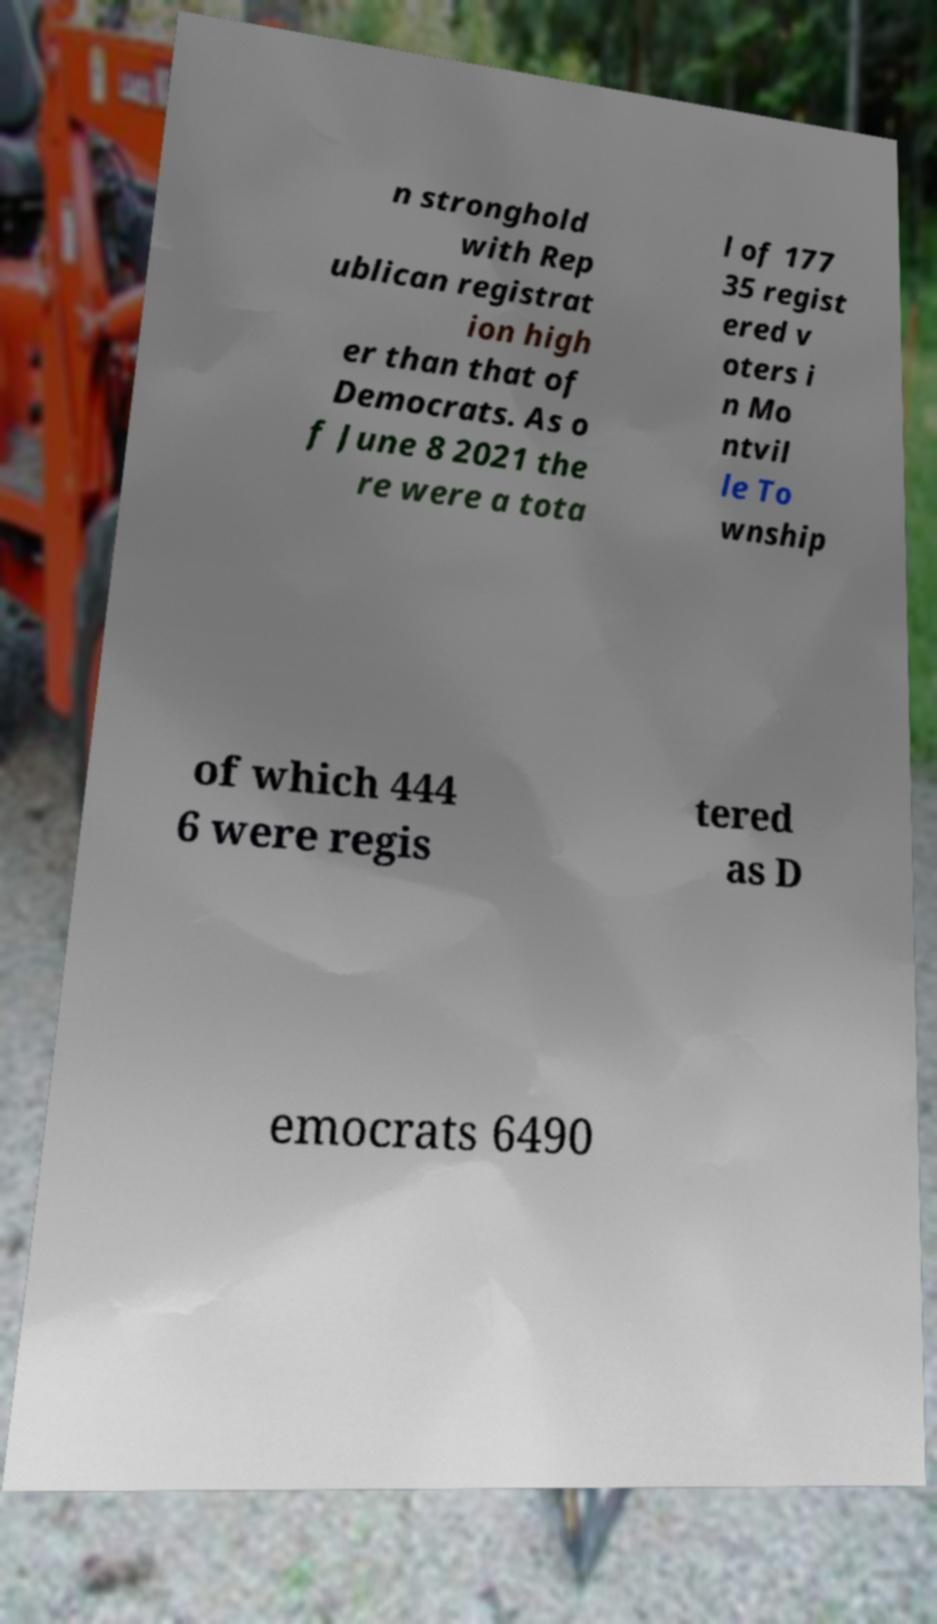Can you read and provide the text displayed in the image?This photo seems to have some interesting text. Can you extract and type it out for me? n stronghold with Rep ublican registrat ion high er than that of Democrats. As o f June 8 2021 the re were a tota l of 177 35 regist ered v oters i n Mo ntvil le To wnship of which 444 6 were regis tered as D emocrats 6490 